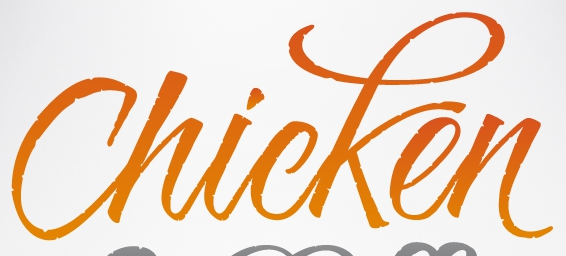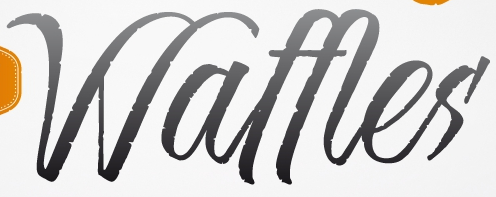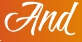What text is displayed in these images sequentially, separated by a semicolon? Chicken; Waffles; And 